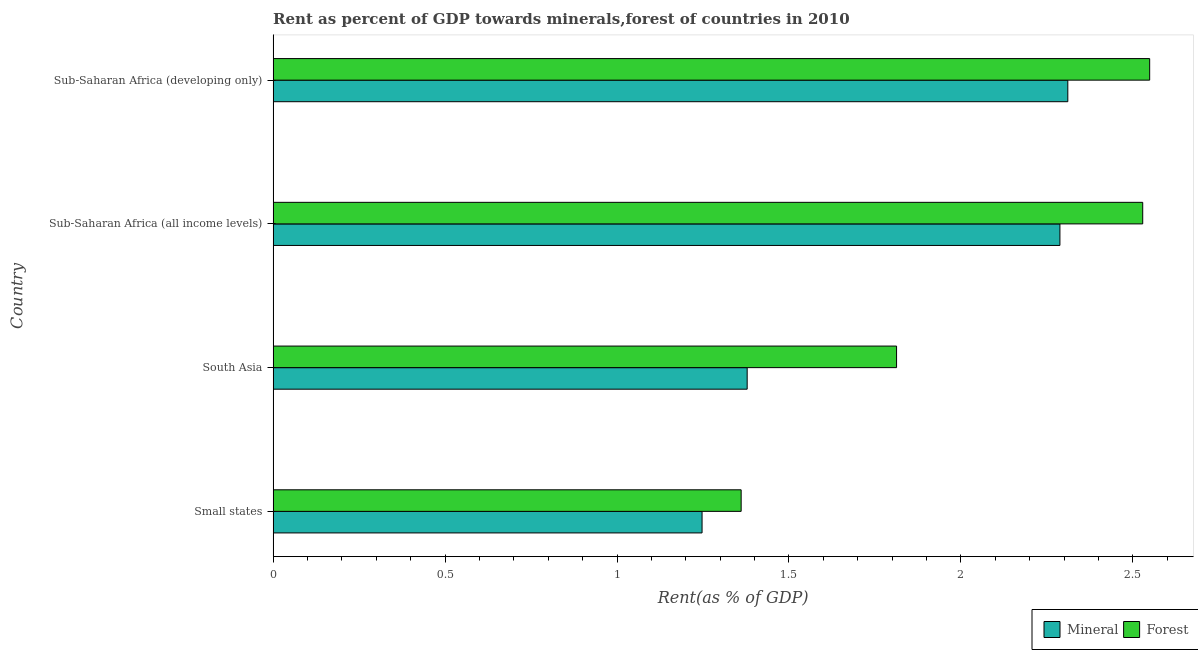How many different coloured bars are there?
Keep it short and to the point. 2. Are the number of bars per tick equal to the number of legend labels?
Make the answer very short. Yes. Are the number of bars on each tick of the Y-axis equal?
Give a very brief answer. Yes. How many bars are there on the 3rd tick from the bottom?
Provide a short and direct response. 2. What is the label of the 2nd group of bars from the top?
Ensure brevity in your answer.  Sub-Saharan Africa (all income levels). What is the forest rent in South Asia?
Offer a terse response. 1.81. Across all countries, what is the maximum mineral rent?
Ensure brevity in your answer.  2.31. Across all countries, what is the minimum forest rent?
Keep it short and to the point. 1.36. In which country was the forest rent maximum?
Provide a short and direct response. Sub-Saharan Africa (developing only). In which country was the mineral rent minimum?
Your answer should be very brief. Small states. What is the total mineral rent in the graph?
Your answer should be compact. 7.22. What is the difference between the mineral rent in Small states and that in South Asia?
Provide a short and direct response. -0.13. What is the difference between the mineral rent in South Asia and the forest rent in Small states?
Your answer should be compact. 0.02. What is the average mineral rent per country?
Ensure brevity in your answer.  1.81. What is the difference between the mineral rent and forest rent in South Asia?
Your answer should be very brief. -0.43. In how many countries, is the forest rent greater than 0.7 %?
Provide a succinct answer. 4. What is the ratio of the forest rent in Small states to that in Sub-Saharan Africa (all income levels)?
Provide a short and direct response. 0.54. Is the forest rent in South Asia less than that in Sub-Saharan Africa (all income levels)?
Give a very brief answer. Yes. What is the difference between the highest and the second highest mineral rent?
Ensure brevity in your answer.  0.02. What is the difference between the highest and the lowest forest rent?
Provide a short and direct response. 1.19. Is the sum of the mineral rent in South Asia and Sub-Saharan Africa (all income levels) greater than the maximum forest rent across all countries?
Make the answer very short. Yes. What does the 2nd bar from the top in Sub-Saharan Africa (developing only) represents?
Your response must be concise. Mineral. What does the 1st bar from the bottom in Sub-Saharan Africa (developing only) represents?
Your response must be concise. Mineral. Are all the bars in the graph horizontal?
Provide a succinct answer. Yes. Are the values on the major ticks of X-axis written in scientific E-notation?
Give a very brief answer. No. Does the graph contain any zero values?
Ensure brevity in your answer.  No. Where does the legend appear in the graph?
Provide a short and direct response. Bottom right. How many legend labels are there?
Offer a terse response. 2. What is the title of the graph?
Offer a terse response. Rent as percent of GDP towards minerals,forest of countries in 2010. Does "Working only" appear as one of the legend labels in the graph?
Provide a short and direct response. No. What is the label or title of the X-axis?
Offer a very short reply. Rent(as % of GDP). What is the Rent(as % of GDP) in Mineral in Small states?
Keep it short and to the point. 1.25. What is the Rent(as % of GDP) in Forest in Small states?
Keep it short and to the point. 1.36. What is the Rent(as % of GDP) in Mineral in South Asia?
Your answer should be very brief. 1.38. What is the Rent(as % of GDP) in Forest in South Asia?
Your answer should be compact. 1.81. What is the Rent(as % of GDP) of Mineral in Sub-Saharan Africa (all income levels)?
Your answer should be very brief. 2.29. What is the Rent(as % of GDP) of Forest in Sub-Saharan Africa (all income levels)?
Make the answer very short. 2.53. What is the Rent(as % of GDP) of Mineral in Sub-Saharan Africa (developing only)?
Your answer should be compact. 2.31. What is the Rent(as % of GDP) of Forest in Sub-Saharan Africa (developing only)?
Your answer should be compact. 2.55. Across all countries, what is the maximum Rent(as % of GDP) in Mineral?
Your answer should be compact. 2.31. Across all countries, what is the maximum Rent(as % of GDP) in Forest?
Offer a very short reply. 2.55. Across all countries, what is the minimum Rent(as % of GDP) of Mineral?
Provide a succinct answer. 1.25. Across all countries, what is the minimum Rent(as % of GDP) in Forest?
Ensure brevity in your answer.  1.36. What is the total Rent(as % of GDP) in Mineral in the graph?
Your answer should be very brief. 7.22. What is the total Rent(as % of GDP) in Forest in the graph?
Your response must be concise. 8.25. What is the difference between the Rent(as % of GDP) of Mineral in Small states and that in South Asia?
Offer a terse response. -0.13. What is the difference between the Rent(as % of GDP) of Forest in Small states and that in South Asia?
Provide a short and direct response. -0.45. What is the difference between the Rent(as % of GDP) of Mineral in Small states and that in Sub-Saharan Africa (all income levels)?
Make the answer very short. -1.04. What is the difference between the Rent(as % of GDP) in Forest in Small states and that in Sub-Saharan Africa (all income levels)?
Your answer should be compact. -1.17. What is the difference between the Rent(as % of GDP) of Mineral in Small states and that in Sub-Saharan Africa (developing only)?
Your answer should be compact. -1.06. What is the difference between the Rent(as % of GDP) in Forest in Small states and that in Sub-Saharan Africa (developing only)?
Your answer should be very brief. -1.19. What is the difference between the Rent(as % of GDP) in Mineral in South Asia and that in Sub-Saharan Africa (all income levels)?
Make the answer very short. -0.91. What is the difference between the Rent(as % of GDP) of Forest in South Asia and that in Sub-Saharan Africa (all income levels)?
Ensure brevity in your answer.  -0.72. What is the difference between the Rent(as % of GDP) of Mineral in South Asia and that in Sub-Saharan Africa (developing only)?
Ensure brevity in your answer.  -0.93. What is the difference between the Rent(as % of GDP) in Forest in South Asia and that in Sub-Saharan Africa (developing only)?
Provide a succinct answer. -0.74. What is the difference between the Rent(as % of GDP) in Mineral in Sub-Saharan Africa (all income levels) and that in Sub-Saharan Africa (developing only)?
Your answer should be very brief. -0.02. What is the difference between the Rent(as % of GDP) in Forest in Sub-Saharan Africa (all income levels) and that in Sub-Saharan Africa (developing only)?
Provide a short and direct response. -0.02. What is the difference between the Rent(as % of GDP) of Mineral in Small states and the Rent(as % of GDP) of Forest in South Asia?
Offer a very short reply. -0.57. What is the difference between the Rent(as % of GDP) in Mineral in Small states and the Rent(as % of GDP) in Forest in Sub-Saharan Africa (all income levels)?
Your response must be concise. -1.28. What is the difference between the Rent(as % of GDP) in Mineral in Small states and the Rent(as % of GDP) in Forest in Sub-Saharan Africa (developing only)?
Offer a terse response. -1.3. What is the difference between the Rent(as % of GDP) of Mineral in South Asia and the Rent(as % of GDP) of Forest in Sub-Saharan Africa (all income levels)?
Give a very brief answer. -1.15. What is the difference between the Rent(as % of GDP) of Mineral in South Asia and the Rent(as % of GDP) of Forest in Sub-Saharan Africa (developing only)?
Give a very brief answer. -1.17. What is the difference between the Rent(as % of GDP) of Mineral in Sub-Saharan Africa (all income levels) and the Rent(as % of GDP) of Forest in Sub-Saharan Africa (developing only)?
Offer a terse response. -0.26. What is the average Rent(as % of GDP) in Mineral per country?
Keep it short and to the point. 1.81. What is the average Rent(as % of GDP) of Forest per country?
Your answer should be very brief. 2.06. What is the difference between the Rent(as % of GDP) in Mineral and Rent(as % of GDP) in Forest in Small states?
Keep it short and to the point. -0.11. What is the difference between the Rent(as % of GDP) of Mineral and Rent(as % of GDP) of Forest in South Asia?
Your answer should be very brief. -0.43. What is the difference between the Rent(as % of GDP) of Mineral and Rent(as % of GDP) of Forest in Sub-Saharan Africa (all income levels)?
Make the answer very short. -0.24. What is the difference between the Rent(as % of GDP) in Mineral and Rent(as % of GDP) in Forest in Sub-Saharan Africa (developing only)?
Keep it short and to the point. -0.24. What is the ratio of the Rent(as % of GDP) of Mineral in Small states to that in South Asia?
Keep it short and to the point. 0.9. What is the ratio of the Rent(as % of GDP) of Forest in Small states to that in South Asia?
Your answer should be very brief. 0.75. What is the ratio of the Rent(as % of GDP) of Mineral in Small states to that in Sub-Saharan Africa (all income levels)?
Provide a succinct answer. 0.55. What is the ratio of the Rent(as % of GDP) of Forest in Small states to that in Sub-Saharan Africa (all income levels)?
Offer a terse response. 0.54. What is the ratio of the Rent(as % of GDP) of Mineral in Small states to that in Sub-Saharan Africa (developing only)?
Your response must be concise. 0.54. What is the ratio of the Rent(as % of GDP) in Forest in Small states to that in Sub-Saharan Africa (developing only)?
Keep it short and to the point. 0.53. What is the ratio of the Rent(as % of GDP) of Mineral in South Asia to that in Sub-Saharan Africa (all income levels)?
Give a very brief answer. 0.6. What is the ratio of the Rent(as % of GDP) of Forest in South Asia to that in Sub-Saharan Africa (all income levels)?
Offer a very short reply. 0.72. What is the ratio of the Rent(as % of GDP) of Mineral in South Asia to that in Sub-Saharan Africa (developing only)?
Offer a very short reply. 0.6. What is the ratio of the Rent(as % of GDP) of Forest in South Asia to that in Sub-Saharan Africa (developing only)?
Your answer should be compact. 0.71. What is the ratio of the Rent(as % of GDP) in Mineral in Sub-Saharan Africa (all income levels) to that in Sub-Saharan Africa (developing only)?
Provide a short and direct response. 0.99. What is the ratio of the Rent(as % of GDP) in Forest in Sub-Saharan Africa (all income levels) to that in Sub-Saharan Africa (developing only)?
Make the answer very short. 0.99. What is the difference between the highest and the second highest Rent(as % of GDP) in Mineral?
Make the answer very short. 0.02. What is the difference between the highest and the second highest Rent(as % of GDP) of Forest?
Keep it short and to the point. 0.02. What is the difference between the highest and the lowest Rent(as % of GDP) in Mineral?
Provide a succinct answer. 1.06. What is the difference between the highest and the lowest Rent(as % of GDP) in Forest?
Keep it short and to the point. 1.19. 